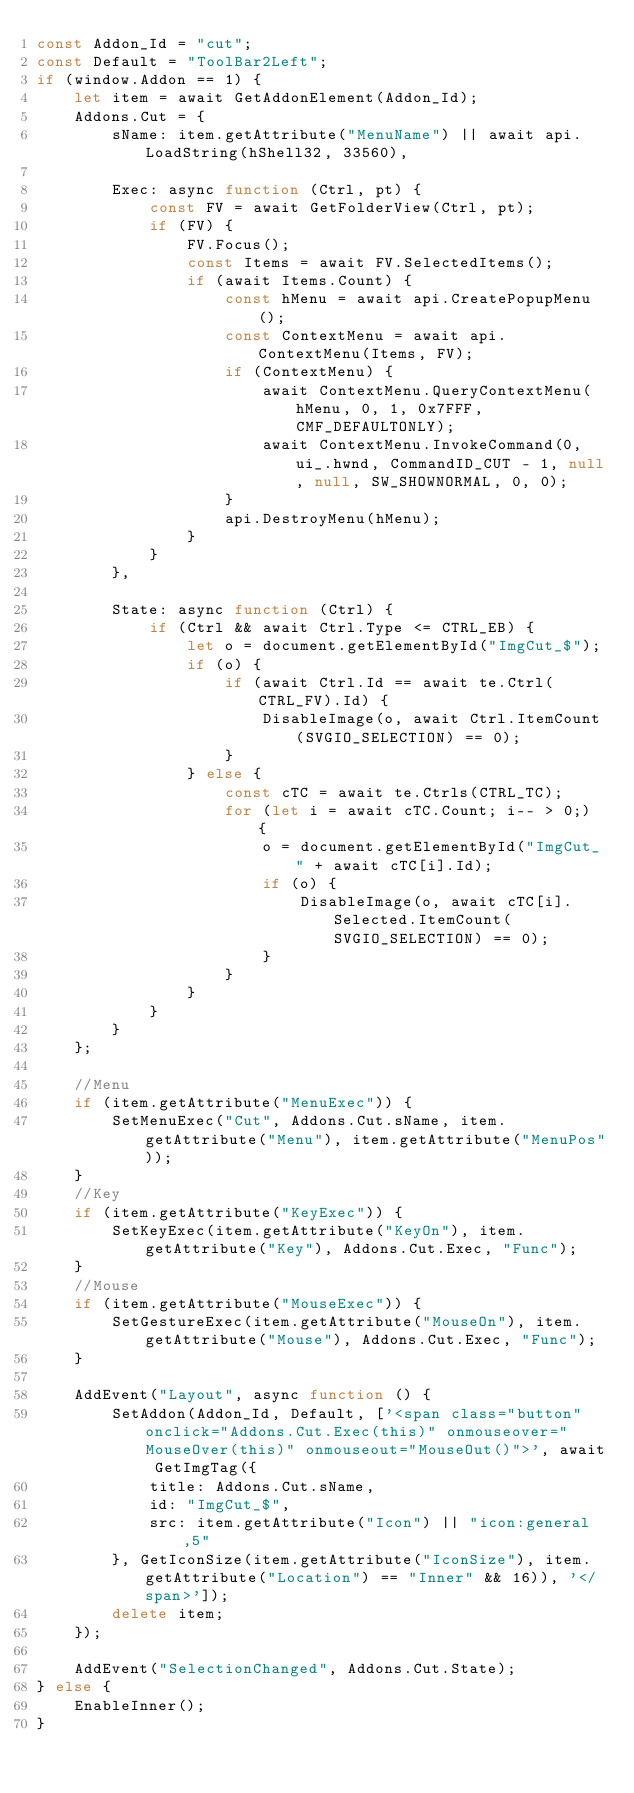<code> <loc_0><loc_0><loc_500><loc_500><_JavaScript_>const Addon_Id = "cut";
const Default = "ToolBar2Left";
if (window.Addon == 1) {
	let item = await GetAddonElement(Addon_Id);
	Addons.Cut = {
		sName: item.getAttribute("MenuName") || await api.LoadString(hShell32, 33560),

		Exec: async function (Ctrl, pt) {
			const FV = await GetFolderView(Ctrl, pt);
			if (FV) {
				FV.Focus();
				const Items = await FV.SelectedItems();
				if (await Items.Count) {
					const hMenu = await api.CreatePopupMenu();
					const ContextMenu = await api.ContextMenu(Items, FV);
					if (ContextMenu) {
						await ContextMenu.QueryContextMenu(hMenu, 0, 1, 0x7FFF, CMF_DEFAULTONLY);
						await ContextMenu.InvokeCommand(0, ui_.hwnd, CommandID_CUT - 1, null, null, SW_SHOWNORMAL, 0, 0);
					}
					api.DestroyMenu(hMenu);
				}
			}
		},

		State: async function (Ctrl) {
			if (Ctrl && await Ctrl.Type <= CTRL_EB) {
				let o = document.getElementById("ImgCut_$");
				if (o) {
					if (await Ctrl.Id == await te.Ctrl(CTRL_FV).Id) {
						DisableImage(o, await Ctrl.ItemCount(SVGIO_SELECTION) == 0);
					}
				} else {
					const cTC = await te.Ctrls(CTRL_TC);
					for (let i = await cTC.Count; i-- > 0;) {
						o = document.getElementById("ImgCut_" + await cTC[i].Id);
						if (o) {
							DisableImage(o, await cTC[i].Selected.ItemCount(SVGIO_SELECTION) == 0);
						}
					}
				}
			}
		}
	};

	//Menu
	if (item.getAttribute("MenuExec")) {
		SetMenuExec("Cut", Addons.Cut.sName, item.getAttribute("Menu"), item.getAttribute("MenuPos"));
	}
	//Key
	if (item.getAttribute("KeyExec")) {
		SetKeyExec(item.getAttribute("KeyOn"), item.getAttribute("Key"), Addons.Cut.Exec, "Func");
	}
	//Mouse
	if (item.getAttribute("MouseExec")) {
		SetGestureExec(item.getAttribute("MouseOn"), item.getAttribute("Mouse"), Addons.Cut.Exec, "Func");
	}

	AddEvent("Layout", async function () {
		SetAddon(Addon_Id, Default, ['<span class="button" onclick="Addons.Cut.Exec(this)" onmouseover="MouseOver(this)" onmouseout="MouseOut()">', await GetImgTag({
			title: Addons.Cut.sName,
			id: "ImgCut_$",
			src: item.getAttribute("Icon") || "icon:general,5"
		}, GetIconSize(item.getAttribute("IconSize"), item.getAttribute("Location") == "Inner" && 16)), '</span>']);
		delete item;
	});

	AddEvent("SelectionChanged", Addons.Cut.State);
} else {
	EnableInner();
}
</code> 